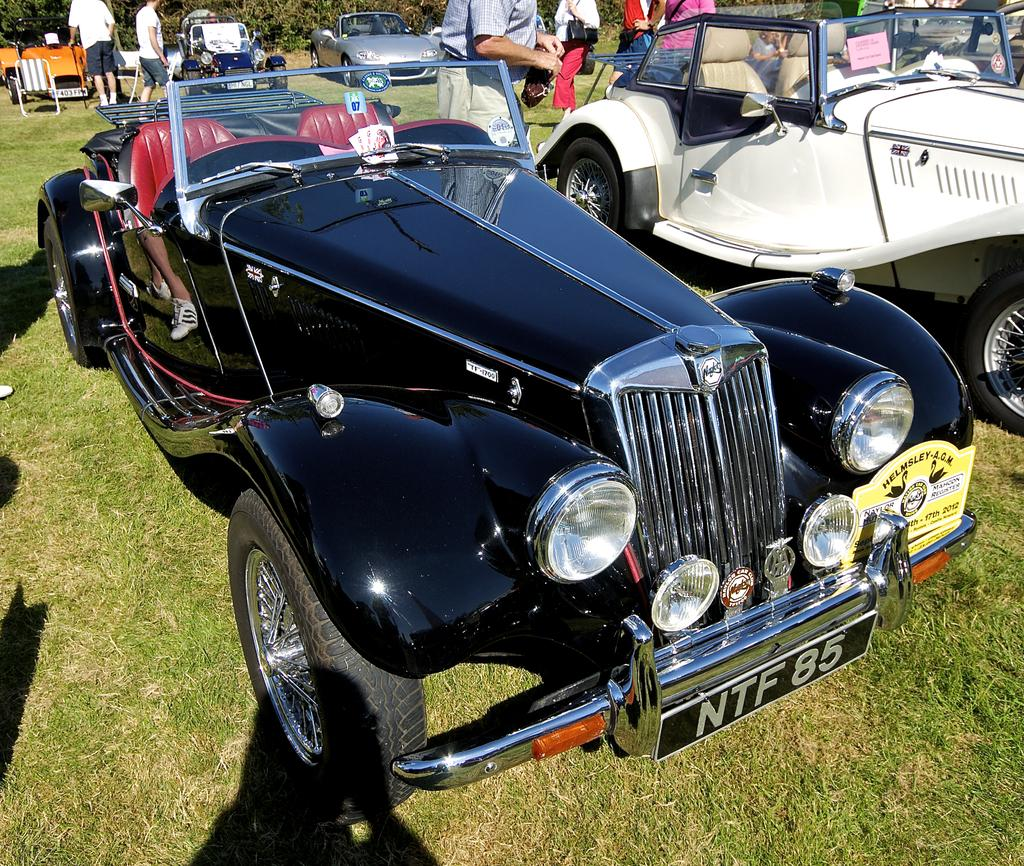What vehicles are located in the center of the image? There are jeeps in the center of the image. What can be seen in the background of the image? There are people and cars in the background of the image. What type of furniture is visible in the image? A chaise lounge is visible in the image. What type of ground surface is at the bottom of the image? There is grass at the bottom of the image. What type of chicken is being used by the carpenter in the image? There is no chicken or carpenter present in the image. What tool is the bucket being used for by the person in the image? There is no bucket present in the image. 